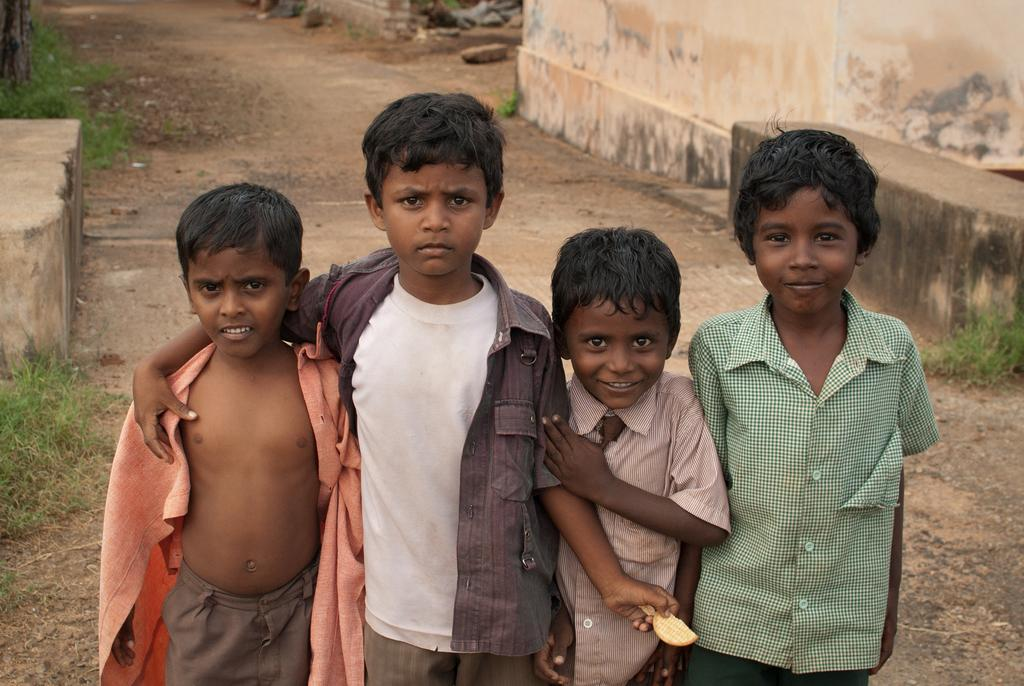How many boys are present in the image? There are four boys in the image. What are the boys doing in the image? The boys are standing. What type of natural environment is visible in the background of the image? There is grass in the background of the image. What type of man-made structure is visible in the background of the image? There is a wall in the background of the image. What year is depicted in the image? The image does not depict a specific year; it is a photograph of four boys standing. How does the wall move around in the image? The wall does not move around in the image; it is a stationary structure in the background. 